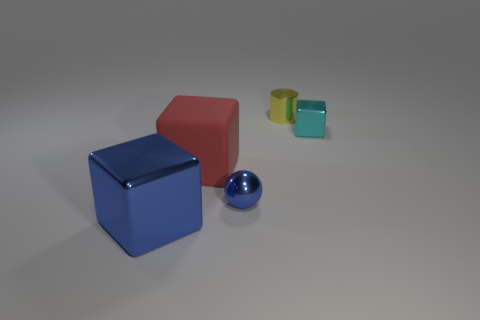Add 4 tiny purple balls. How many objects exist? 9 Subtract all spheres. How many objects are left? 4 Add 3 shiny balls. How many shiny balls are left? 4 Add 4 shiny cubes. How many shiny cubes exist? 6 Subtract 1 cyan cubes. How many objects are left? 4 Subtract all small yellow cylinders. Subtract all cyan metallic objects. How many objects are left? 3 